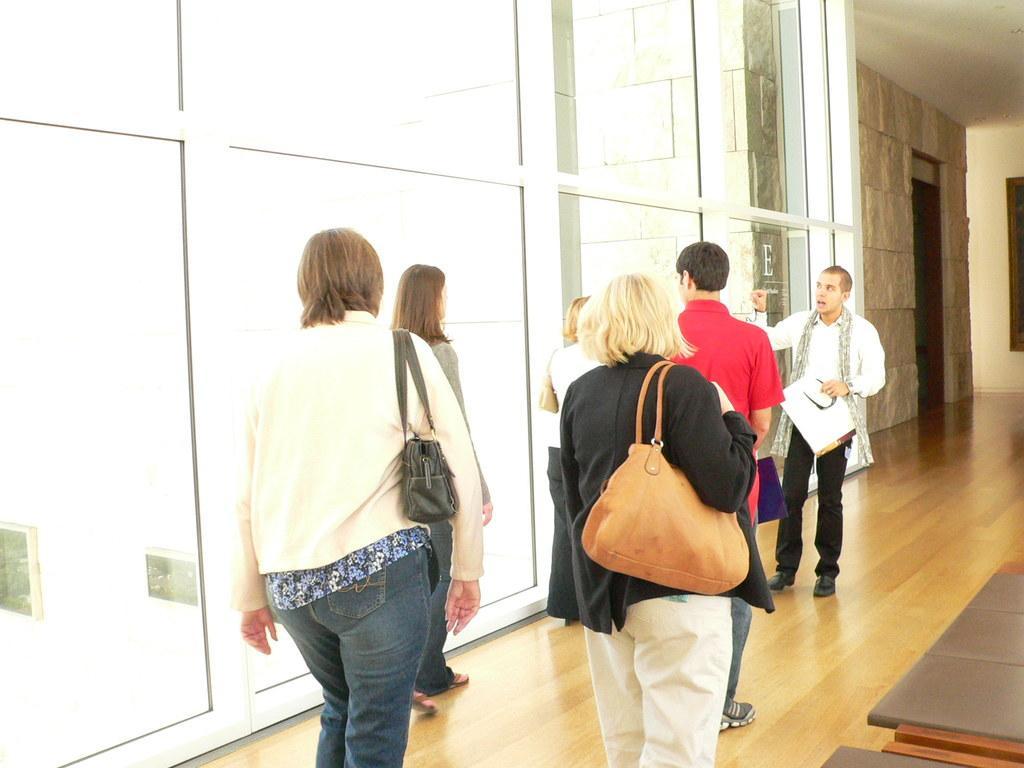How would you summarize this image in a sentence or two? In this image I can see number of people where two of them are men and rest all are women. Here I can see floor and also I can see few women carrying their handbags. 